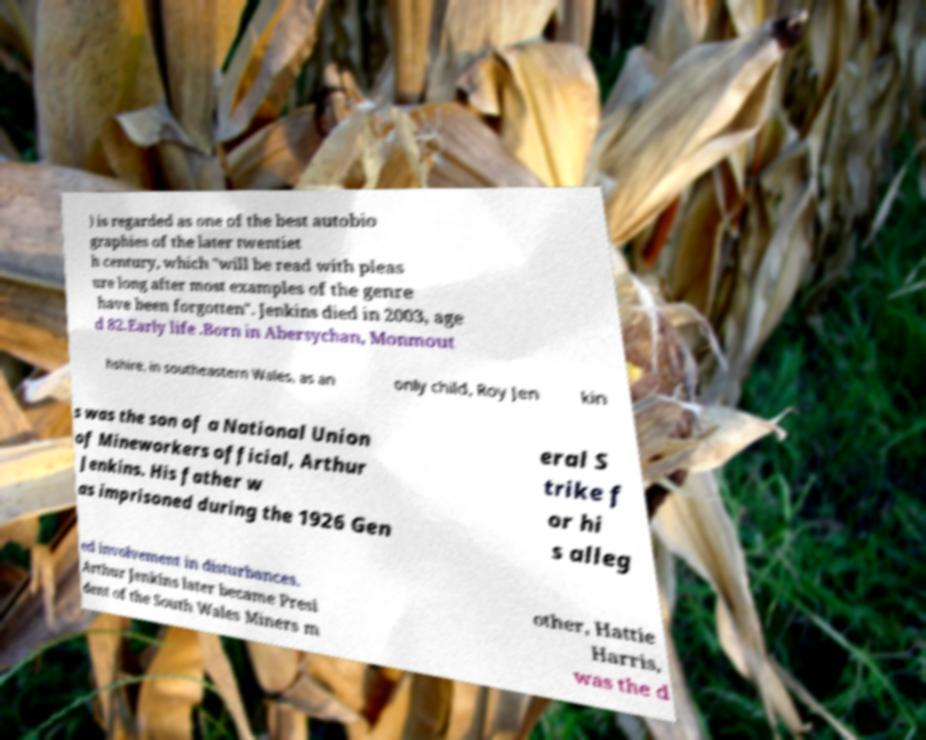Could you extract and type out the text from this image? ) is regarded as one of the best autobio graphies of the later twentiet h century, which "will be read with pleas ure long after most examples of the genre have been forgotten". Jenkins died in 2003, age d 82.Early life .Born in Abersychan, Monmout hshire, in southeastern Wales, as an only child, Roy Jen kin s was the son of a National Union of Mineworkers official, Arthur Jenkins. His father w as imprisoned during the 1926 Gen eral S trike f or hi s alleg ed involvement in disturbances. Arthur Jenkins later became Presi dent of the South Wales Miners m other, Hattie Harris, was the d 